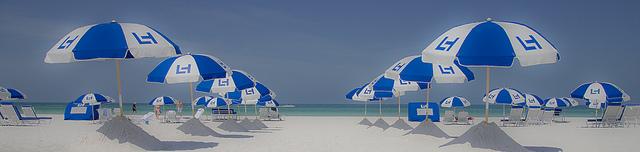Is the image in black and white?
Write a very short answer. No. Is there people on the beach?
Be succinct. Yes. Are all umbrellas the same color?
Write a very short answer. Yes. Does this view have an animated quality to it?
Short answer required. Yes. 